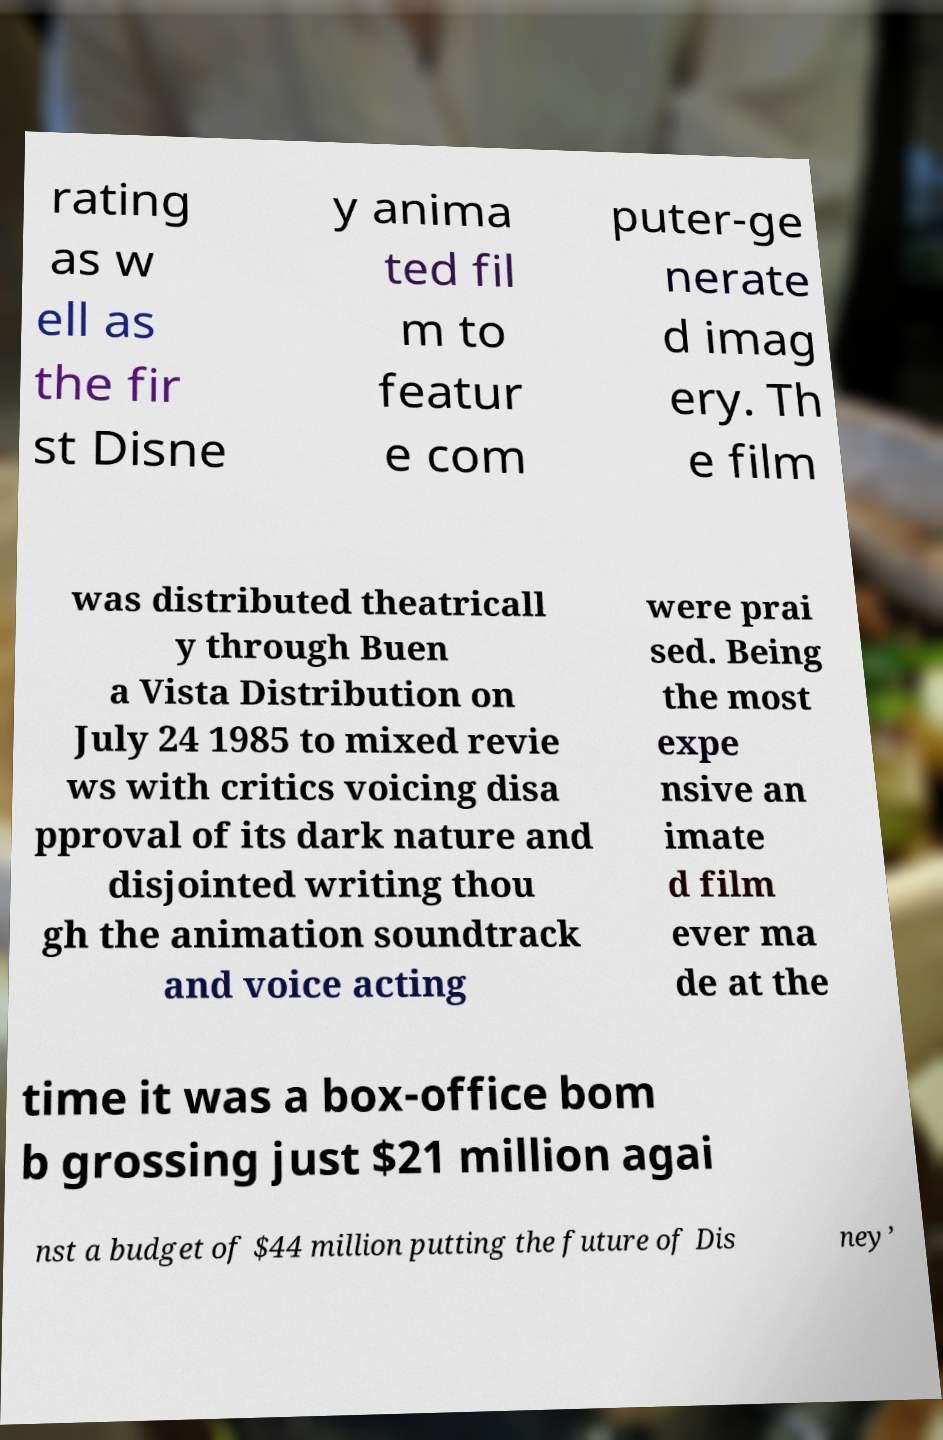Please read and relay the text visible in this image. What does it say? rating as w ell as the fir st Disne y anima ted fil m to featur e com puter-ge nerate d imag ery. Th e film was distributed theatricall y through Buen a Vista Distribution on July 24 1985 to mixed revie ws with critics voicing disa pproval of its dark nature and disjointed writing thou gh the animation soundtrack and voice acting were prai sed. Being the most expe nsive an imate d film ever ma de at the time it was a box-office bom b grossing just $21 million agai nst a budget of $44 million putting the future of Dis ney’ 